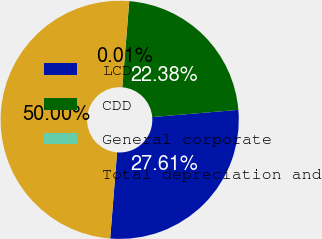Convert chart. <chart><loc_0><loc_0><loc_500><loc_500><pie_chart><fcel>LCD<fcel>CDD<fcel>General corporate<fcel>Total depreciation and<nl><fcel>27.61%<fcel>22.38%<fcel>0.01%<fcel>50.0%<nl></chart> 